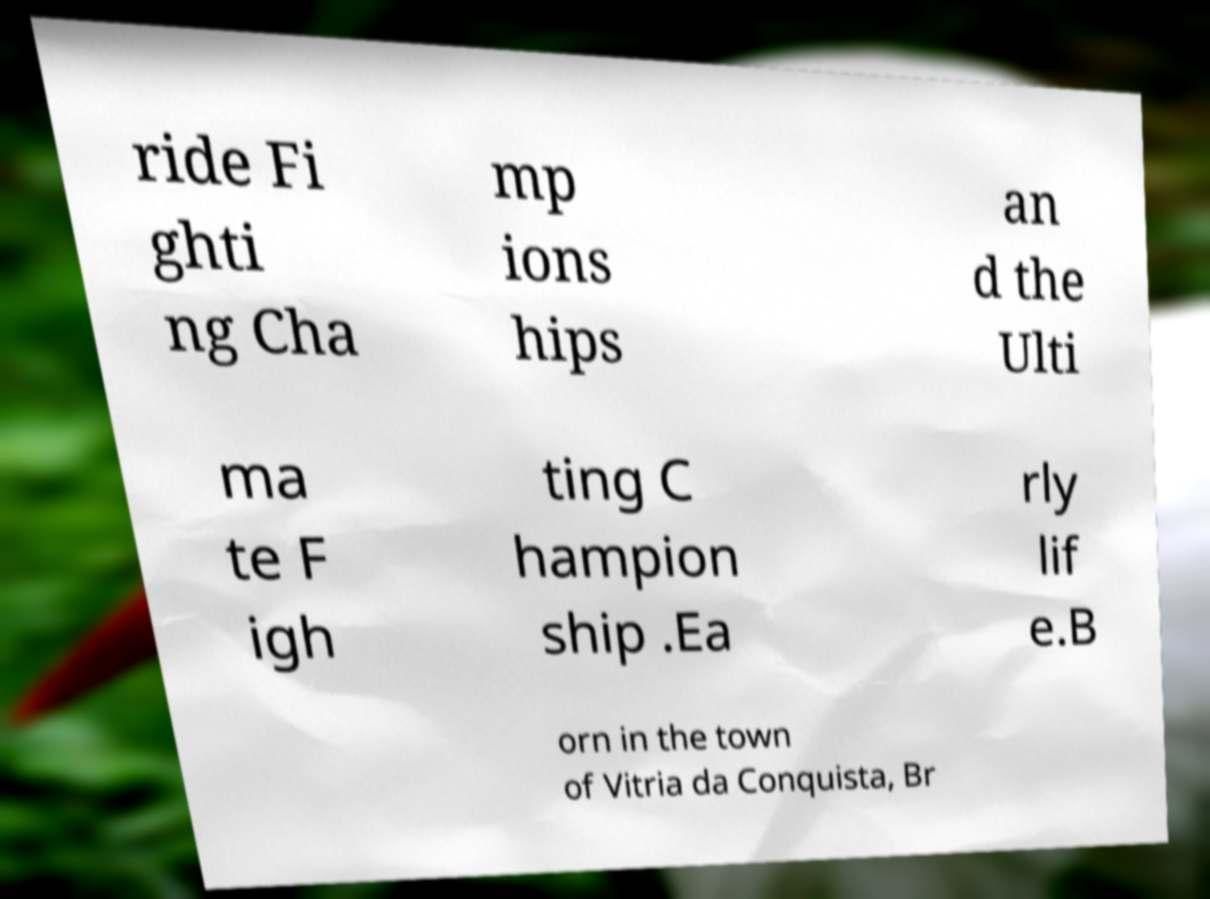Please read and relay the text visible in this image. What does it say? ride Fi ghti ng Cha mp ions hips an d the Ulti ma te F igh ting C hampion ship .Ea rly lif e.B orn in the town of Vitria da Conquista, Br 